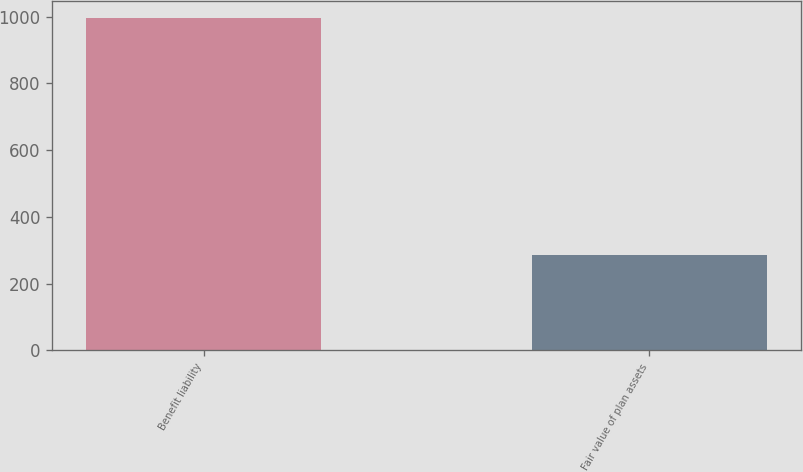Convert chart to OTSL. <chart><loc_0><loc_0><loc_500><loc_500><bar_chart><fcel>Benefit liability<fcel>Fair value of plan assets<nl><fcel>996<fcel>285<nl></chart> 